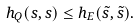<formula> <loc_0><loc_0><loc_500><loc_500>h _ { Q } ( s , s ) \leq h _ { E } ( \tilde { s } , \tilde { s } ) .</formula> 